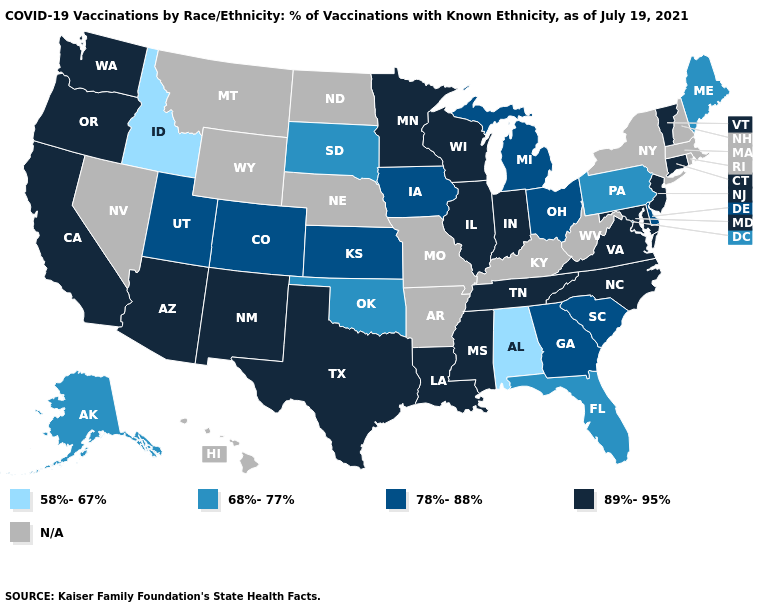Name the states that have a value in the range N/A?
Answer briefly. Arkansas, Hawaii, Kentucky, Massachusetts, Missouri, Montana, Nebraska, Nevada, New Hampshire, New York, North Dakota, Rhode Island, West Virginia, Wyoming. Name the states that have a value in the range N/A?
Answer briefly. Arkansas, Hawaii, Kentucky, Massachusetts, Missouri, Montana, Nebraska, Nevada, New Hampshire, New York, North Dakota, Rhode Island, West Virginia, Wyoming. Which states have the lowest value in the USA?
Keep it brief. Alabama, Idaho. Among the states that border Alabama , which have the lowest value?
Concise answer only. Florida. Name the states that have a value in the range 89%-95%?
Write a very short answer. Arizona, California, Connecticut, Illinois, Indiana, Louisiana, Maryland, Minnesota, Mississippi, New Jersey, New Mexico, North Carolina, Oregon, Tennessee, Texas, Vermont, Virginia, Washington, Wisconsin. How many symbols are there in the legend?
Concise answer only. 5. Name the states that have a value in the range 89%-95%?
Short answer required. Arizona, California, Connecticut, Illinois, Indiana, Louisiana, Maryland, Minnesota, Mississippi, New Jersey, New Mexico, North Carolina, Oregon, Tennessee, Texas, Vermont, Virginia, Washington, Wisconsin. Does Alabama have the lowest value in the USA?
Write a very short answer. Yes. Name the states that have a value in the range N/A?
Be succinct. Arkansas, Hawaii, Kentucky, Massachusetts, Missouri, Montana, Nebraska, Nevada, New Hampshire, New York, North Dakota, Rhode Island, West Virginia, Wyoming. Name the states that have a value in the range N/A?
Quick response, please. Arkansas, Hawaii, Kentucky, Massachusetts, Missouri, Montana, Nebraska, Nevada, New Hampshire, New York, North Dakota, Rhode Island, West Virginia, Wyoming. Name the states that have a value in the range 68%-77%?
Write a very short answer. Alaska, Florida, Maine, Oklahoma, Pennsylvania, South Dakota. Name the states that have a value in the range 78%-88%?
Concise answer only. Colorado, Delaware, Georgia, Iowa, Kansas, Michigan, Ohio, South Carolina, Utah. Name the states that have a value in the range 68%-77%?
Be succinct. Alaska, Florida, Maine, Oklahoma, Pennsylvania, South Dakota. 